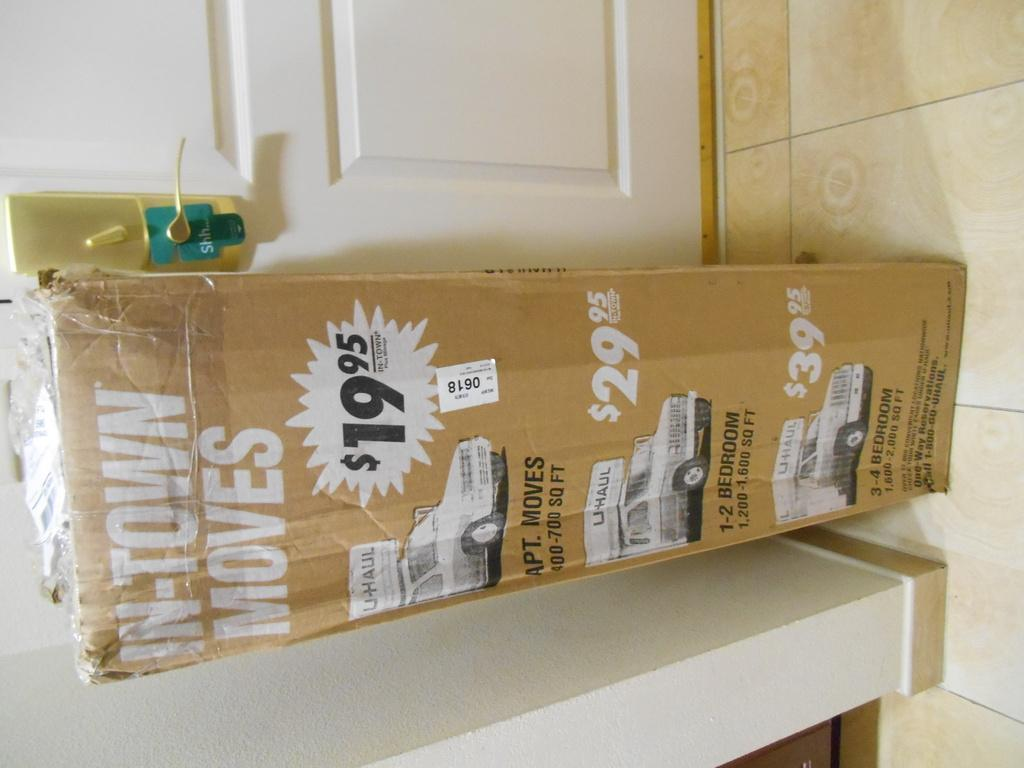<image>
Provide a brief description of the given image. a box reading In-Town Moves $19.95 an other prices on it 